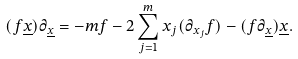Convert formula to latex. <formula><loc_0><loc_0><loc_500><loc_500>( f \underline { x } ) \partial _ { \underline { x } } = - m f - 2 \sum _ { j = 1 } ^ { m } x _ { j } ( \partial _ { x _ { j } } f ) - ( f \partial _ { \underline { x } } ) \underline { x } .</formula> 